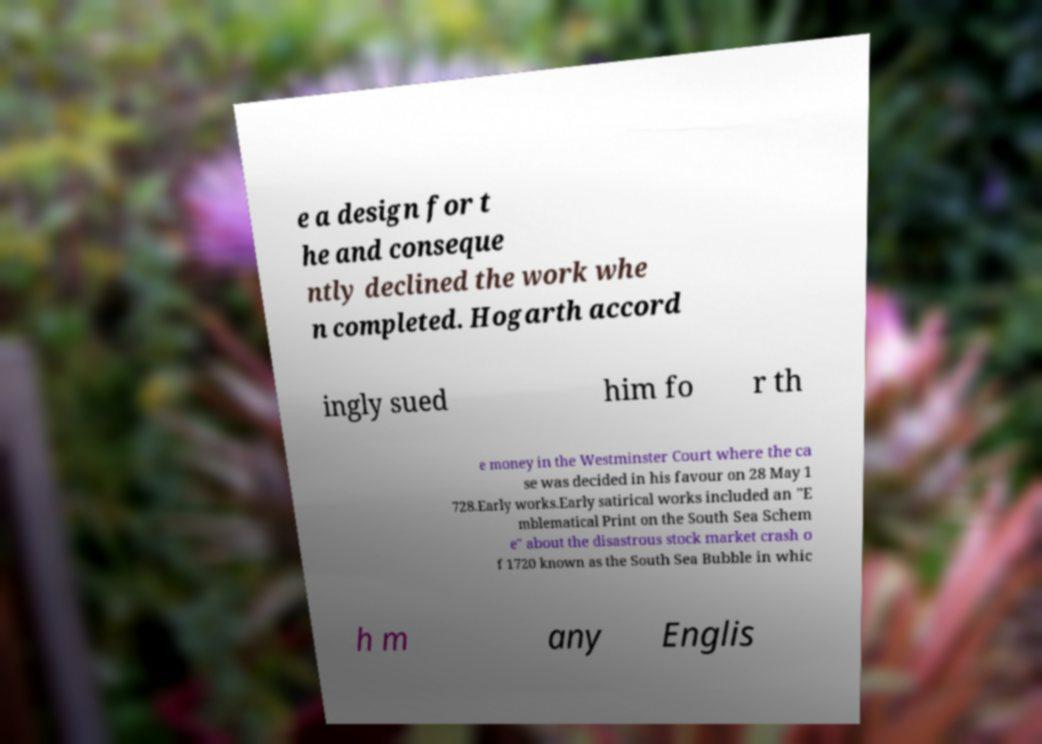Please read and relay the text visible in this image. What does it say? e a design for t he and conseque ntly declined the work whe n completed. Hogarth accord ingly sued him fo r th e money in the Westminster Court where the ca se was decided in his favour on 28 May 1 728.Early works.Early satirical works included an "E mblematical Print on the South Sea Schem e" about the disastrous stock market crash o f 1720 known as the South Sea Bubble in whic h m any Englis 